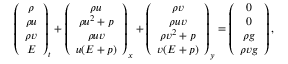Convert formula to latex. <formula><loc_0><loc_0><loc_500><loc_500>\left ( \begin{array} { c } { \rho } \\ { \rho u } \\ { \rho v } \\ { E } \end{array} \right ) _ { t } + \left ( \begin{array} { c } { \rho u } \\ { \rho u ^ { 2 } + p } \\ { \rho u v } \\ { u ( E + p ) } \end{array} \right ) _ { x } + \left ( \begin{array} { c } { \rho v } \\ { \rho u v } \\ { \rho v ^ { 2 } + p } \\ { v ( E + p ) } \end{array} \right ) _ { y } = \left ( \begin{array} { c } { 0 } \\ { 0 } \\ { \rho g } \\ { \rho v g } \end{array} \right ) ,</formula> 